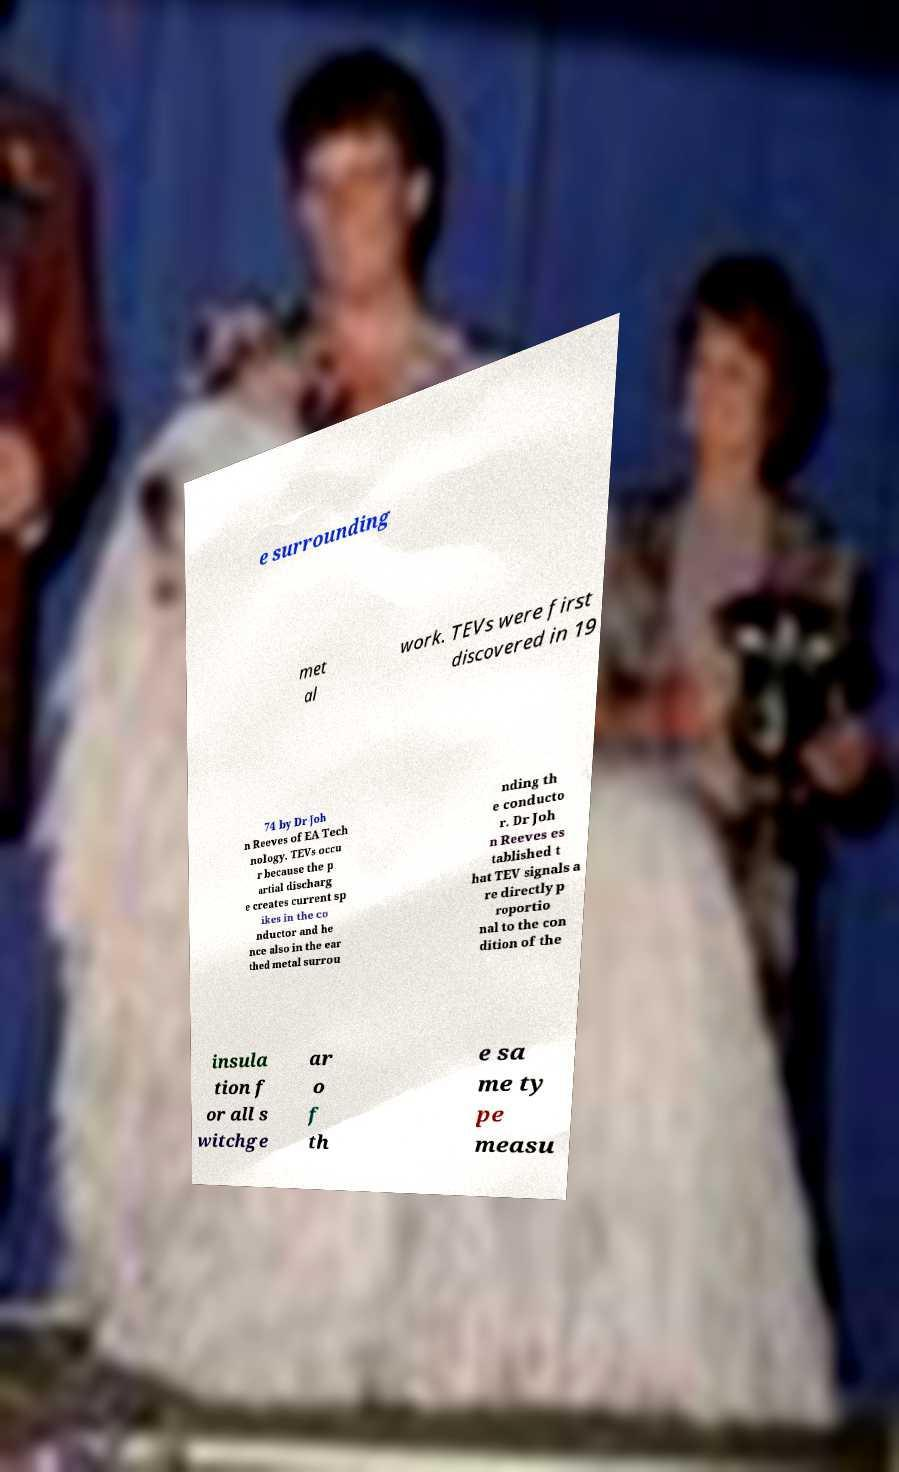I need the written content from this picture converted into text. Can you do that? e surrounding met al work. TEVs were first discovered in 19 74 by Dr Joh n Reeves of EA Tech nology. TEVs occu r because the p artial discharg e creates current sp ikes in the co nductor and he nce also in the ear thed metal surrou nding th e conducto r. Dr Joh n Reeves es tablished t hat TEV signals a re directly p roportio nal to the con dition of the insula tion f or all s witchge ar o f th e sa me ty pe measu 